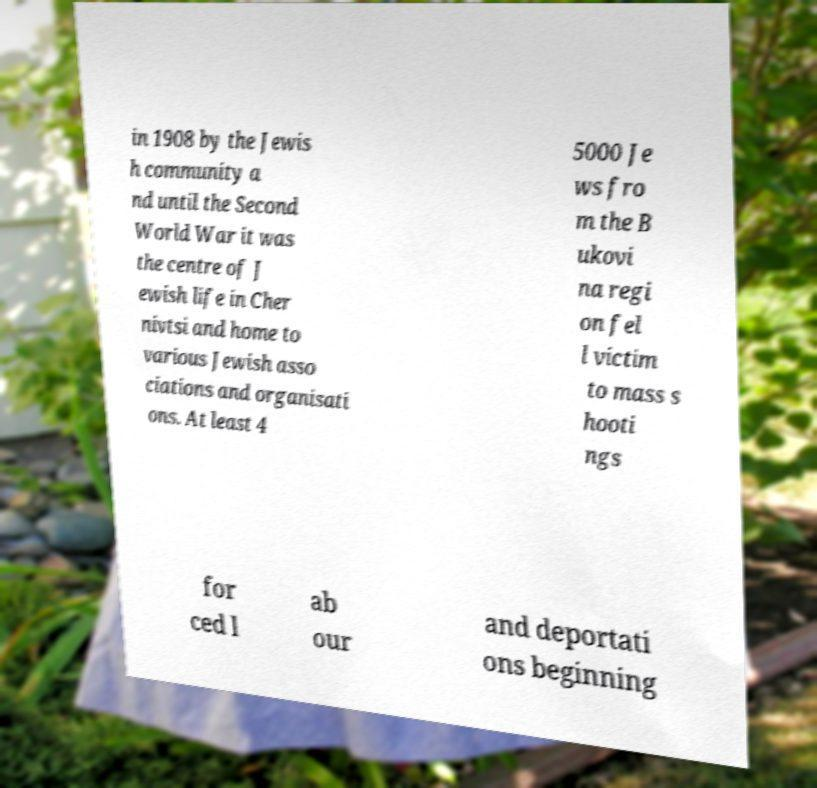Please identify and transcribe the text found in this image. in 1908 by the Jewis h community a nd until the Second World War it was the centre of J ewish life in Cher nivtsi and home to various Jewish asso ciations and organisati ons. At least 4 5000 Je ws fro m the B ukovi na regi on fel l victim to mass s hooti ngs for ced l ab our and deportati ons beginning 